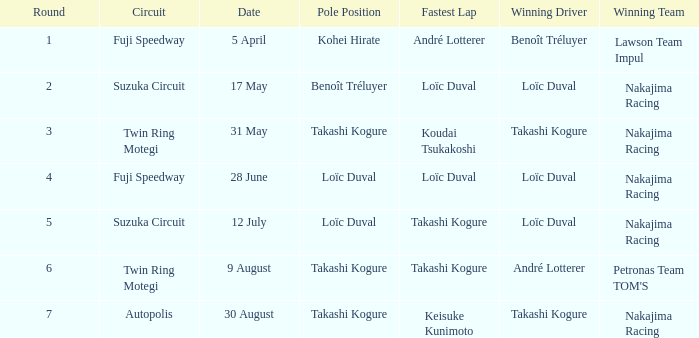Who has the fastest lap where Benoît Tréluyer got the pole position? Loïc Duval. 